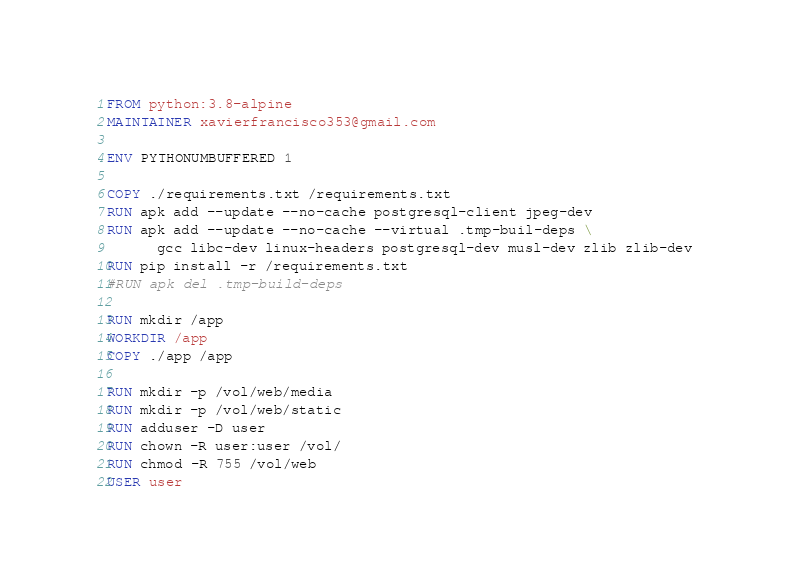Convert code to text. <code><loc_0><loc_0><loc_500><loc_500><_Dockerfile_>FROM python:3.8-alpine
MAINTAINER xavierfrancisco353@gmail.com

ENV PYTHONUMBUFFERED 1

COPY ./requirements.txt /requirements.txt
RUN apk add --update --no-cache postgresql-client jpeg-dev
RUN apk add --update --no-cache --virtual .tmp-buil-deps \
      gcc libc-dev linux-headers postgresql-dev musl-dev zlib zlib-dev
RUN pip install -r /requirements.txt
#RUN apk del .tmp-build-deps

RUN mkdir /app
WORKDIR /app
COPY ./app /app

RUN mkdir -p /vol/web/media
RUN mkdir -p /vol/web/static
RUN adduser -D user
RUN chown -R user:user /vol/
RUN chmod -R 755 /vol/web
USER user</code> 